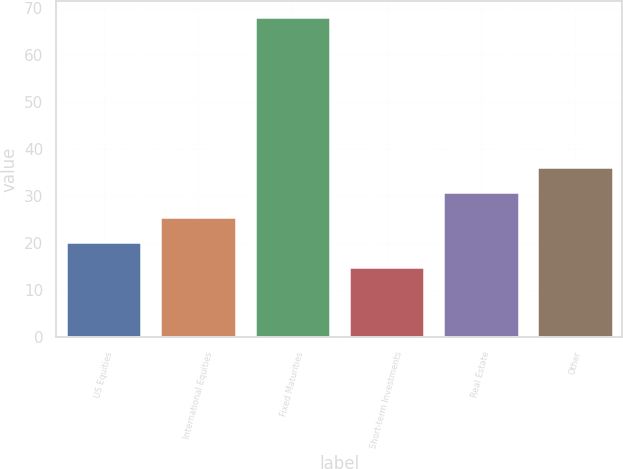Convert chart to OTSL. <chart><loc_0><loc_0><loc_500><loc_500><bar_chart><fcel>US Equities<fcel>International Equities<fcel>Fixed Maturities<fcel>Short-term Investments<fcel>Real Estate<fcel>Other<nl><fcel>20.3<fcel>25.6<fcel>68<fcel>15<fcel>30.9<fcel>36.2<nl></chart> 